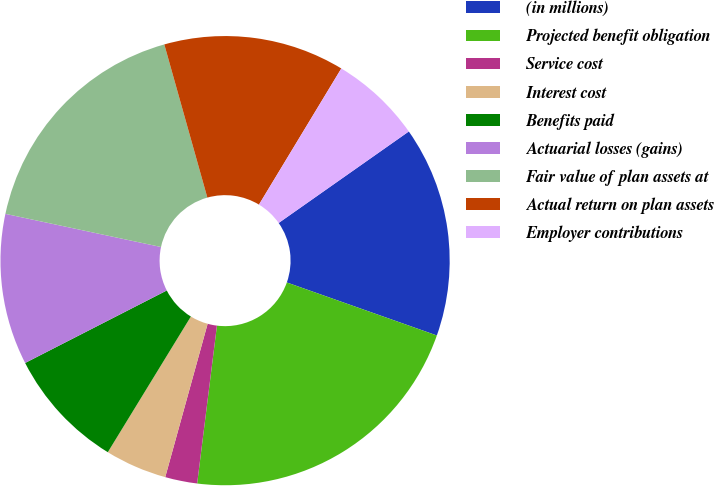Convert chart. <chart><loc_0><loc_0><loc_500><loc_500><pie_chart><fcel>(in millions)<fcel>Projected benefit obligation<fcel>Service cost<fcel>Interest cost<fcel>Benefits paid<fcel>Actuarial losses (gains)<fcel>Fair value of plan assets at<fcel>Actual return on plan assets<fcel>Employer contributions<nl><fcel>15.16%<fcel>21.58%<fcel>2.31%<fcel>4.45%<fcel>8.73%<fcel>10.87%<fcel>17.3%<fcel>13.02%<fcel>6.59%<nl></chart> 